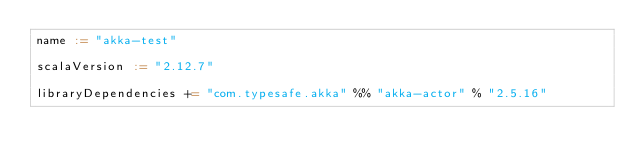<code> <loc_0><loc_0><loc_500><loc_500><_Scala_>name := "akka-test"

scalaVersion := "2.12.7"

libraryDependencies += "com.typesafe.akka" %% "akka-actor" % "2.5.16"
</code> 